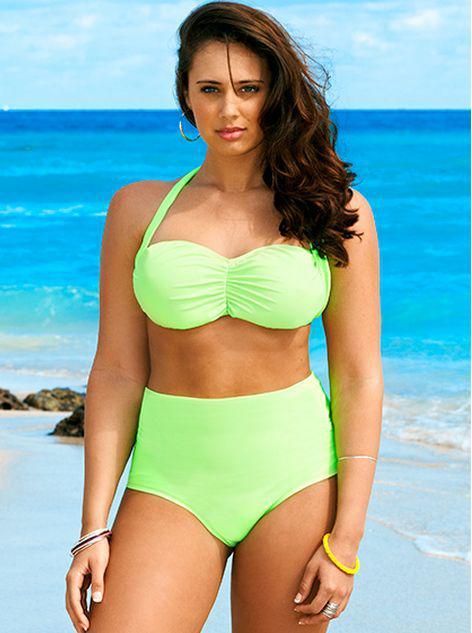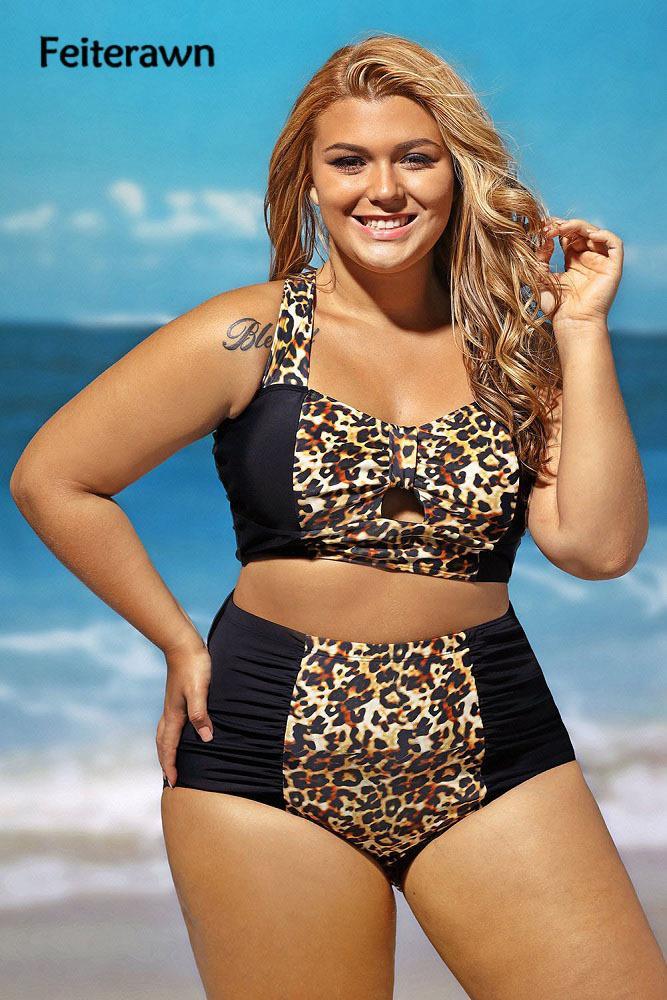The first image is the image on the left, the second image is the image on the right. Given the left and right images, does the statement "A woman is wearing a solid black two piece bathing suit." hold true? Answer yes or no. No. The first image is the image on the left, the second image is the image on the right. For the images shown, is this caption "the same model is wearing a bright green bikini" true? Answer yes or no. Yes. 